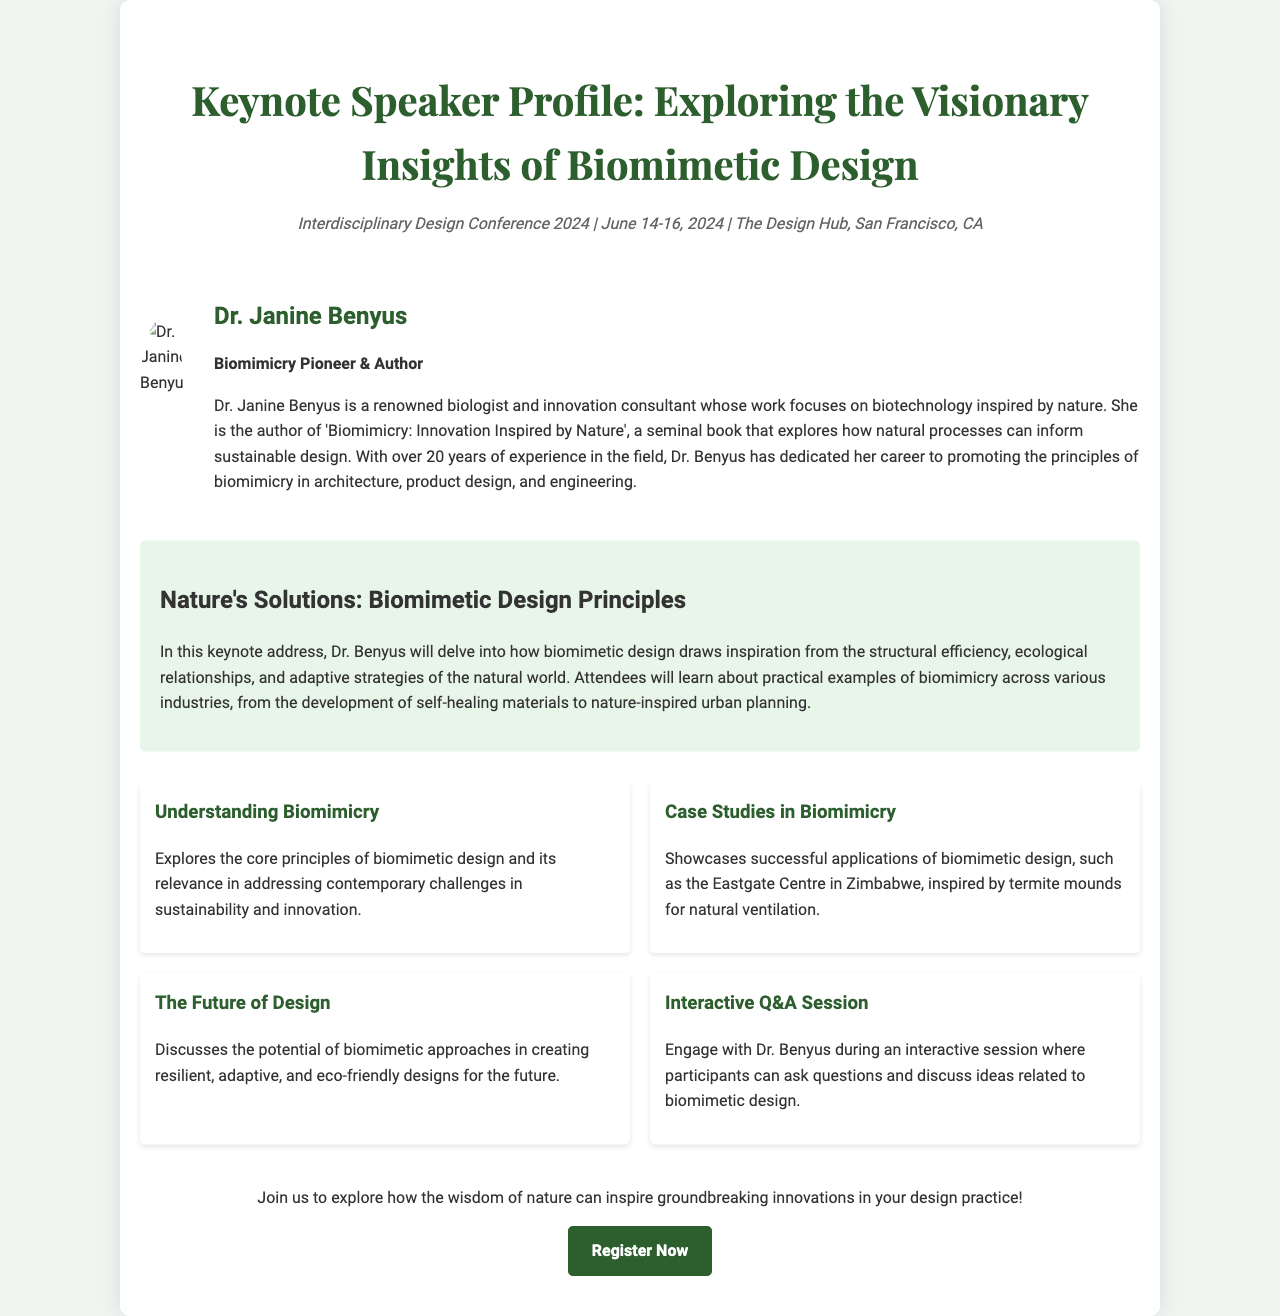What is the name of the keynote speaker? The name of the keynote speaker is mentioned in the document as Dr. Janine Benyus.
Answer: Dr. Janine Benyus What is the title of Dr. Benyus's seminal book? The document specifies the title of Dr. Benyus's book, which explores biomimicry as 'Biomimicry: Innovation Inspired by Nature'.
Answer: Biomimicry: Innovation Inspired by Nature When will the conference take place? The date of the conference is stated in the document as June 14-16, 2024.
Answer: June 14-16, 2024 What is one application of biomimetic design mentioned? The document highlights that the Eastgate Centre in Zimbabwe is an example of biomimetic design inspired by termite mounds for natural ventilation.
Answer: Eastgate Centre in Zimbabwe What will attendees learn about in the keynote address? The keynote address will focus on how biomimetic design draws inspiration from natural ecological relationships and adaptive strategies.
Answer: Natural ecological relationships and adaptive strategies What type of session will be available for participants? The document mentions an interactive Q&A session where participants can engage with Dr. Benyus.
Answer: Interactive Q&A session What is the location of the conference? The location of the conference is detailed in the document as The Design Hub, San Francisco, CA.
Answer: The Design Hub, San Francisco, CA What is the main theme of Dr. Benyus's presentation? The theme of Dr. Benyus's presentation is focused on biomimetic design principles, specifically framed as "Nature's Solutions."
Answer: Nature's Solutions 